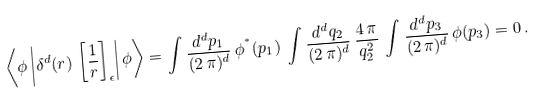<formula> <loc_0><loc_0><loc_500><loc_500>\left \langle \phi \left | \delta ^ { d } ( r ) \, \left [ \frac { 1 } { r } \right ] _ { \epsilon } \right | \phi \right \rangle = \int \frac { d ^ { d } p _ { 1 } } { ( 2 \, \pi ) ^ { d } } \, \phi ^ { ^ { * } } ( p _ { 1 } ) \, \int \frac { d ^ { d } q _ { 2 } } { ( 2 \, \pi ) ^ { d } } \, \frac { 4 \, \pi } { q _ { 2 } ^ { 2 } } \, \int \frac { d ^ { d } p _ { 3 } } { ( 2 \, \pi ) ^ { d } } \, \phi ( p _ { 3 } ) = 0 \, .</formula> 